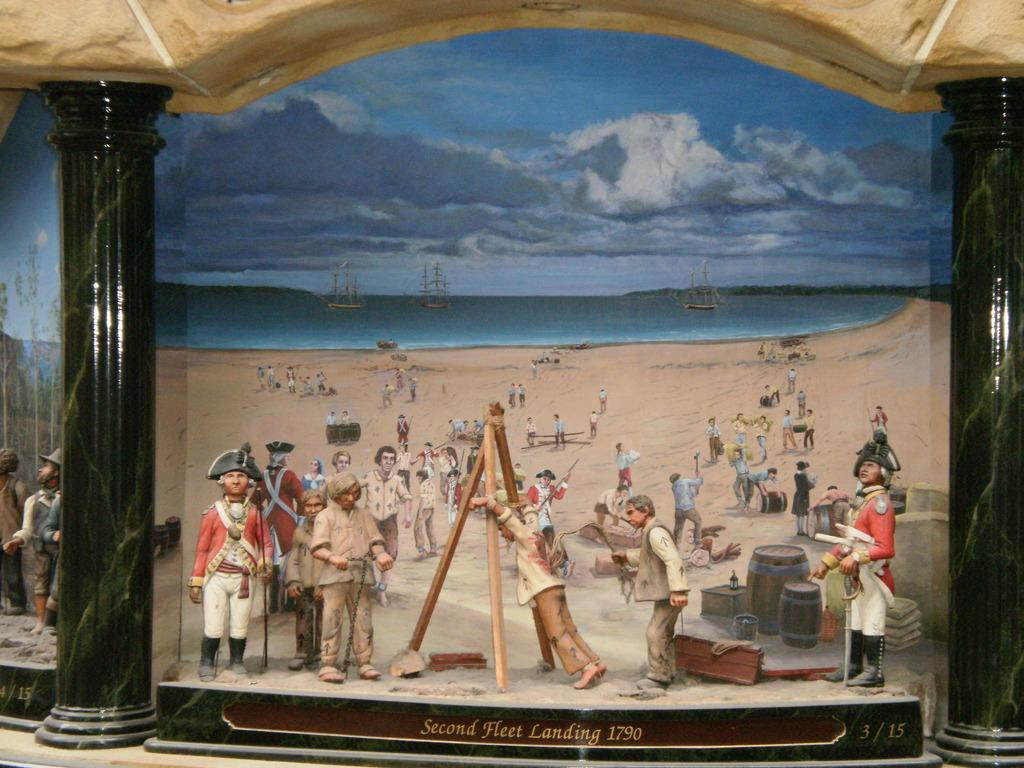<image>
Offer a succinct explanation of the picture presented. A painting of the Second Fleet Landing of 1790. 